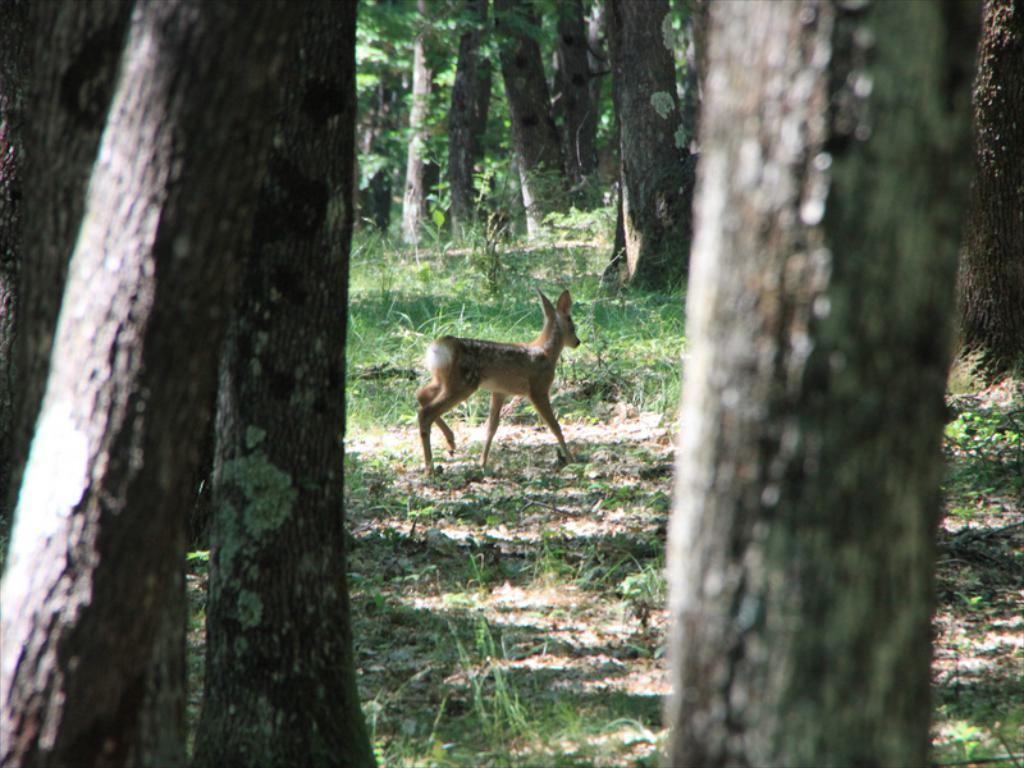In one or two sentences, can you explain what this image depicts? In this image we can see few trees, grass and a deer on the ground. 